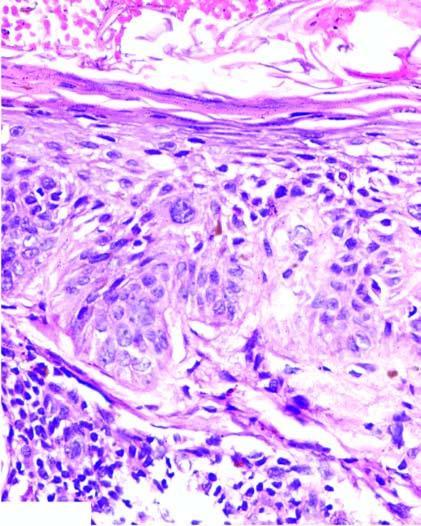what is effaced?
Answer the question using a single word or phrase. Normal base to surface maturation of epidermal layers 